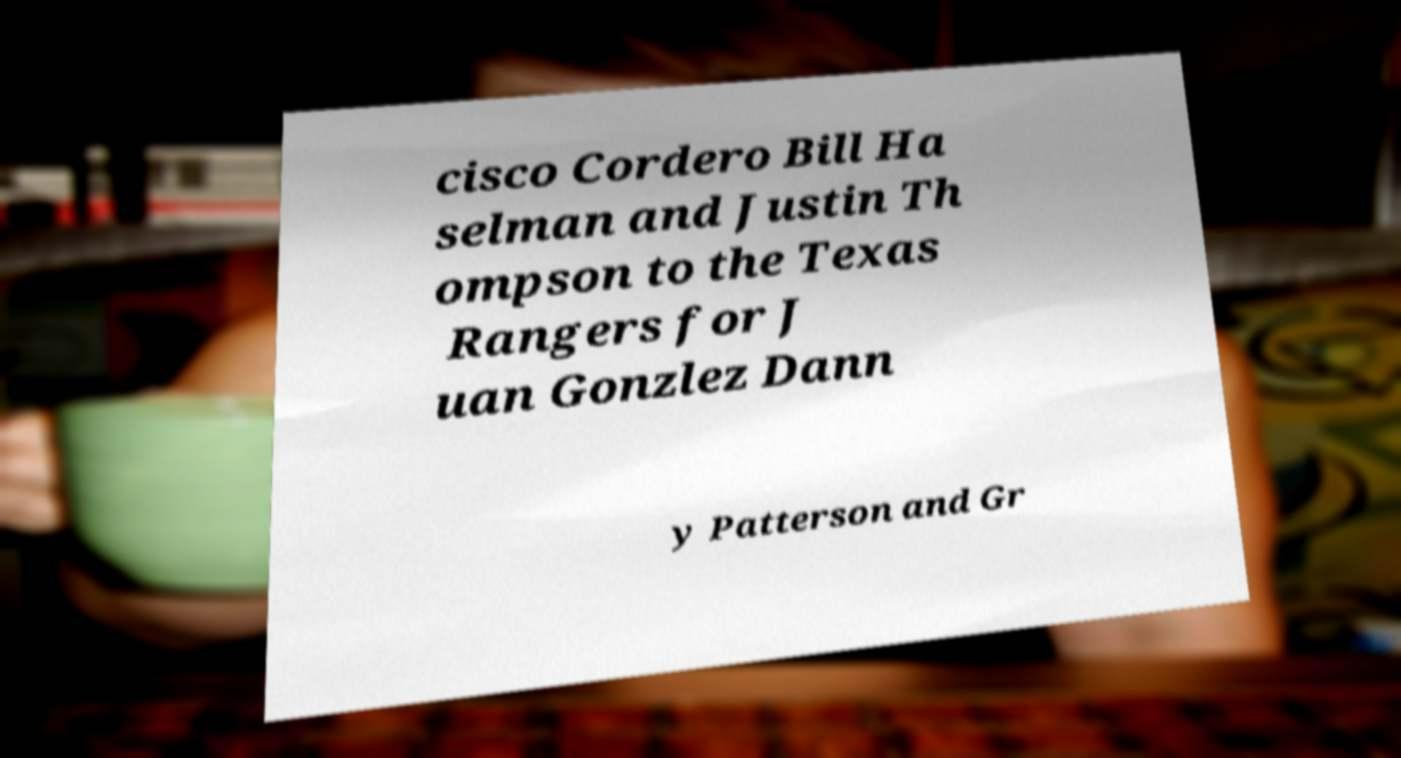Can you read and provide the text displayed in the image?This photo seems to have some interesting text. Can you extract and type it out for me? cisco Cordero Bill Ha selman and Justin Th ompson to the Texas Rangers for J uan Gonzlez Dann y Patterson and Gr 